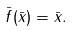Convert formula to latex. <formula><loc_0><loc_0><loc_500><loc_500>\bar { f } ( \bar { x } ) = \bar { x } . \text { }</formula> 